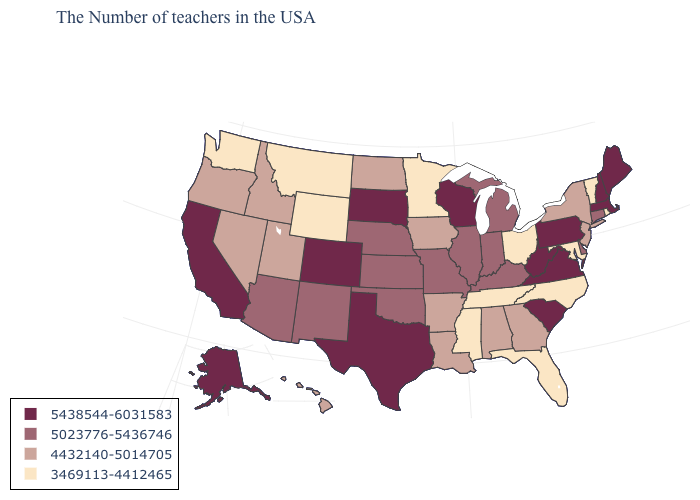What is the value of Nebraska?
Be succinct. 5023776-5436746. Does Arizona have the same value as Connecticut?
Write a very short answer. Yes. What is the value of Hawaii?
Be succinct. 4432140-5014705. Among the states that border New York , does Massachusetts have the lowest value?
Quick response, please. No. Among the states that border Mississippi , does Tennessee have the highest value?
Answer briefly. No. What is the value of Iowa?
Be succinct. 4432140-5014705. Name the states that have a value in the range 5023776-5436746?
Give a very brief answer. Connecticut, Delaware, Michigan, Kentucky, Indiana, Illinois, Missouri, Kansas, Nebraska, Oklahoma, New Mexico, Arizona. Does Wisconsin have the highest value in the MidWest?
Short answer required. Yes. Name the states that have a value in the range 3469113-4412465?
Quick response, please. Rhode Island, Vermont, Maryland, North Carolina, Ohio, Florida, Tennessee, Mississippi, Minnesota, Wyoming, Montana, Washington. Among the states that border Louisiana , which have the lowest value?
Be succinct. Mississippi. Name the states that have a value in the range 4432140-5014705?
Quick response, please. New York, New Jersey, Georgia, Alabama, Louisiana, Arkansas, Iowa, North Dakota, Utah, Idaho, Nevada, Oregon, Hawaii. Which states have the lowest value in the South?
Keep it brief. Maryland, North Carolina, Florida, Tennessee, Mississippi. Name the states that have a value in the range 3469113-4412465?
Write a very short answer. Rhode Island, Vermont, Maryland, North Carolina, Ohio, Florida, Tennessee, Mississippi, Minnesota, Wyoming, Montana, Washington. What is the value of Michigan?
Short answer required. 5023776-5436746. Does Vermont have the lowest value in the Northeast?
Write a very short answer. Yes. 